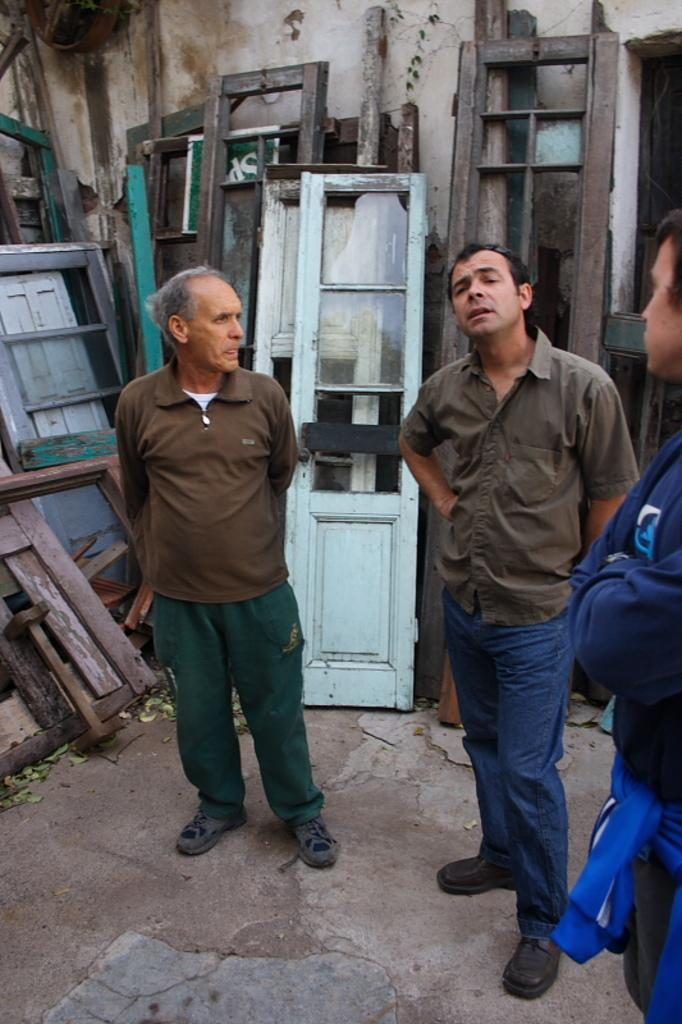What is happening in the image involving the people? The people in the image are standing and talking to each other. Can you describe the wooden objects in the background? Unfortunately, the provided facts do not give any information about the wooden objects in the background. What might be a reason for the people to be talking to each other? The reason for the people talking to each other is not mentioned in the provided facts. What type of cap is the person wearing in the image? There is no mention of a cap or any headwear in the provided facts. How many arms does the person have in the image? The provided facts do not mention the number of arms the person has. 